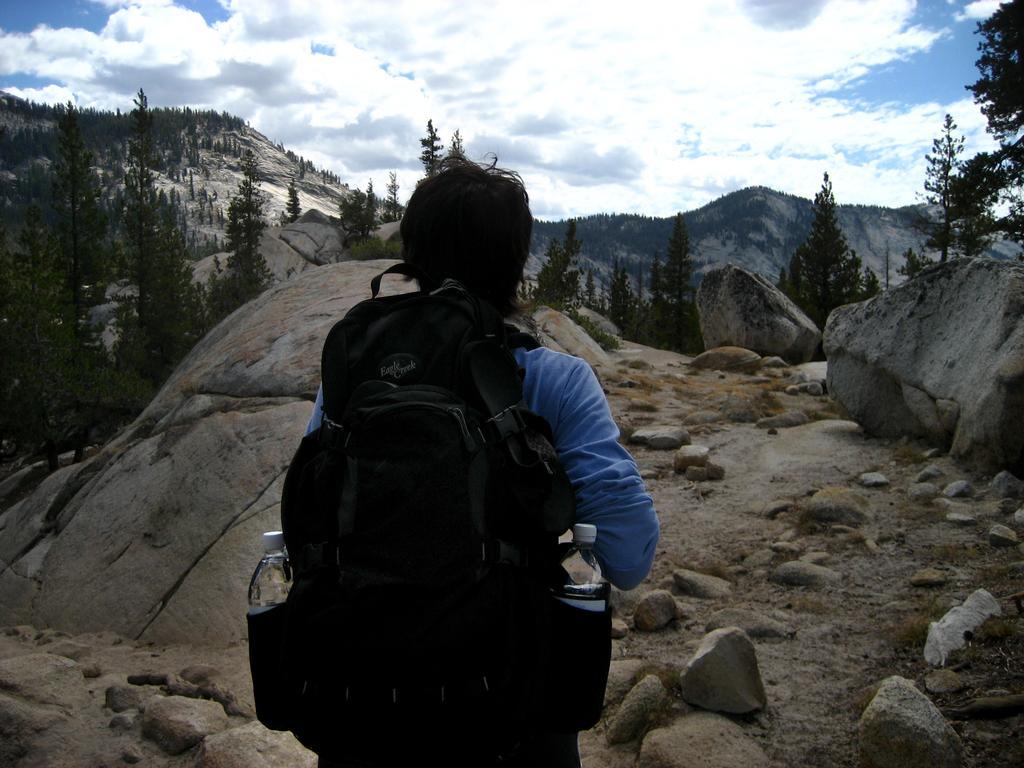How would you summarize this image in a sentence or two? In this Image I see a person who is carrying a bag and there are 2 bottles in it. In the background I see the rocks, trees, mountain and the sky. 